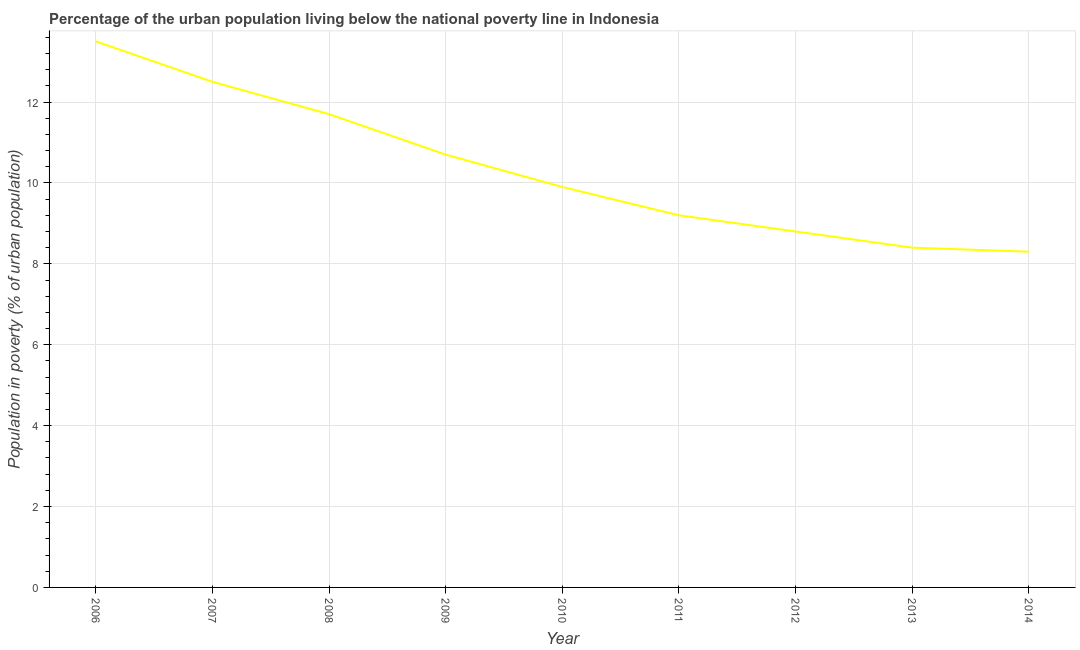What is the percentage of urban population living below poverty line in 2012?
Give a very brief answer. 8.8. What is the sum of the percentage of urban population living below poverty line?
Ensure brevity in your answer.  93. What is the difference between the percentage of urban population living below poverty line in 2007 and 2010?
Provide a succinct answer. 2.6. What is the average percentage of urban population living below poverty line per year?
Your response must be concise. 10.33. In how many years, is the percentage of urban population living below poverty line greater than 10.4 %?
Ensure brevity in your answer.  4. What is the difference between the highest and the second highest percentage of urban population living below poverty line?
Offer a terse response. 1. Is the sum of the percentage of urban population living below poverty line in 2012 and 2014 greater than the maximum percentage of urban population living below poverty line across all years?
Ensure brevity in your answer.  Yes. What is the difference between the highest and the lowest percentage of urban population living below poverty line?
Your answer should be compact. 5.2. In how many years, is the percentage of urban population living below poverty line greater than the average percentage of urban population living below poverty line taken over all years?
Offer a very short reply. 4. How many years are there in the graph?
Keep it short and to the point. 9. What is the difference between two consecutive major ticks on the Y-axis?
Keep it short and to the point. 2. Does the graph contain grids?
Offer a terse response. Yes. What is the title of the graph?
Provide a succinct answer. Percentage of the urban population living below the national poverty line in Indonesia. What is the label or title of the Y-axis?
Make the answer very short. Population in poverty (% of urban population). What is the Population in poverty (% of urban population) of 2009?
Provide a short and direct response. 10.7. What is the Population in poverty (% of urban population) of 2010?
Your answer should be very brief. 9.9. What is the Population in poverty (% of urban population) of 2011?
Ensure brevity in your answer.  9.2. What is the Population in poverty (% of urban population) in 2012?
Ensure brevity in your answer.  8.8. What is the difference between the Population in poverty (% of urban population) in 2006 and 2007?
Your answer should be very brief. 1. What is the difference between the Population in poverty (% of urban population) in 2006 and 2008?
Provide a succinct answer. 1.8. What is the difference between the Population in poverty (% of urban population) in 2006 and 2012?
Keep it short and to the point. 4.7. What is the difference between the Population in poverty (% of urban population) in 2007 and 2008?
Your answer should be very brief. 0.8. What is the difference between the Population in poverty (% of urban population) in 2007 and 2011?
Give a very brief answer. 3.3. What is the difference between the Population in poverty (% of urban population) in 2007 and 2012?
Your answer should be compact. 3.7. What is the difference between the Population in poverty (% of urban population) in 2008 and 2010?
Your answer should be very brief. 1.8. What is the difference between the Population in poverty (% of urban population) in 2008 and 2012?
Provide a short and direct response. 2.9. What is the difference between the Population in poverty (% of urban population) in 2009 and 2010?
Provide a succinct answer. 0.8. What is the difference between the Population in poverty (% of urban population) in 2009 and 2011?
Give a very brief answer. 1.5. What is the difference between the Population in poverty (% of urban population) in 2009 and 2014?
Your response must be concise. 2.4. What is the difference between the Population in poverty (% of urban population) in 2010 and 2012?
Offer a very short reply. 1.1. What is the difference between the Population in poverty (% of urban population) in 2010 and 2013?
Offer a terse response. 1.5. What is the difference between the Population in poverty (% of urban population) in 2010 and 2014?
Your answer should be compact. 1.6. What is the difference between the Population in poverty (% of urban population) in 2011 and 2014?
Give a very brief answer. 0.9. What is the difference between the Population in poverty (% of urban population) in 2013 and 2014?
Keep it short and to the point. 0.1. What is the ratio of the Population in poverty (% of urban population) in 2006 to that in 2007?
Offer a terse response. 1.08. What is the ratio of the Population in poverty (% of urban population) in 2006 to that in 2008?
Offer a terse response. 1.15. What is the ratio of the Population in poverty (% of urban population) in 2006 to that in 2009?
Keep it short and to the point. 1.26. What is the ratio of the Population in poverty (% of urban population) in 2006 to that in 2010?
Offer a terse response. 1.36. What is the ratio of the Population in poverty (% of urban population) in 2006 to that in 2011?
Keep it short and to the point. 1.47. What is the ratio of the Population in poverty (% of urban population) in 2006 to that in 2012?
Your answer should be compact. 1.53. What is the ratio of the Population in poverty (% of urban population) in 2006 to that in 2013?
Your answer should be compact. 1.61. What is the ratio of the Population in poverty (% of urban population) in 2006 to that in 2014?
Provide a short and direct response. 1.63. What is the ratio of the Population in poverty (% of urban population) in 2007 to that in 2008?
Your response must be concise. 1.07. What is the ratio of the Population in poverty (% of urban population) in 2007 to that in 2009?
Give a very brief answer. 1.17. What is the ratio of the Population in poverty (% of urban population) in 2007 to that in 2010?
Provide a short and direct response. 1.26. What is the ratio of the Population in poverty (% of urban population) in 2007 to that in 2011?
Your answer should be compact. 1.36. What is the ratio of the Population in poverty (% of urban population) in 2007 to that in 2012?
Provide a succinct answer. 1.42. What is the ratio of the Population in poverty (% of urban population) in 2007 to that in 2013?
Your answer should be compact. 1.49. What is the ratio of the Population in poverty (% of urban population) in 2007 to that in 2014?
Give a very brief answer. 1.51. What is the ratio of the Population in poverty (% of urban population) in 2008 to that in 2009?
Your answer should be very brief. 1.09. What is the ratio of the Population in poverty (% of urban population) in 2008 to that in 2010?
Your response must be concise. 1.18. What is the ratio of the Population in poverty (% of urban population) in 2008 to that in 2011?
Provide a short and direct response. 1.27. What is the ratio of the Population in poverty (% of urban population) in 2008 to that in 2012?
Offer a terse response. 1.33. What is the ratio of the Population in poverty (% of urban population) in 2008 to that in 2013?
Your answer should be compact. 1.39. What is the ratio of the Population in poverty (% of urban population) in 2008 to that in 2014?
Keep it short and to the point. 1.41. What is the ratio of the Population in poverty (% of urban population) in 2009 to that in 2010?
Give a very brief answer. 1.08. What is the ratio of the Population in poverty (% of urban population) in 2009 to that in 2011?
Your response must be concise. 1.16. What is the ratio of the Population in poverty (% of urban population) in 2009 to that in 2012?
Your response must be concise. 1.22. What is the ratio of the Population in poverty (% of urban population) in 2009 to that in 2013?
Ensure brevity in your answer.  1.27. What is the ratio of the Population in poverty (% of urban population) in 2009 to that in 2014?
Provide a short and direct response. 1.29. What is the ratio of the Population in poverty (% of urban population) in 2010 to that in 2011?
Ensure brevity in your answer.  1.08. What is the ratio of the Population in poverty (% of urban population) in 2010 to that in 2013?
Give a very brief answer. 1.18. What is the ratio of the Population in poverty (% of urban population) in 2010 to that in 2014?
Ensure brevity in your answer.  1.19. What is the ratio of the Population in poverty (% of urban population) in 2011 to that in 2012?
Provide a short and direct response. 1.04. What is the ratio of the Population in poverty (% of urban population) in 2011 to that in 2013?
Give a very brief answer. 1.09. What is the ratio of the Population in poverty (% of urban population) in 2011 to that in 2014?
Keep it short and to the point. 1.11. What is the ratio of the Population in poverty (% of urban population) in 2012 to that in 2013?
Your response must be concise. 1.05. What is the ratio of the Population in poverty (% of urban population) in 2012 to that in 2014?
Your answer should be very brief. 1.06. What is the ratio of the Population in poverty (% of urban population) in 2013 to that in 2014?
Offer a very short reply. 1.01. 